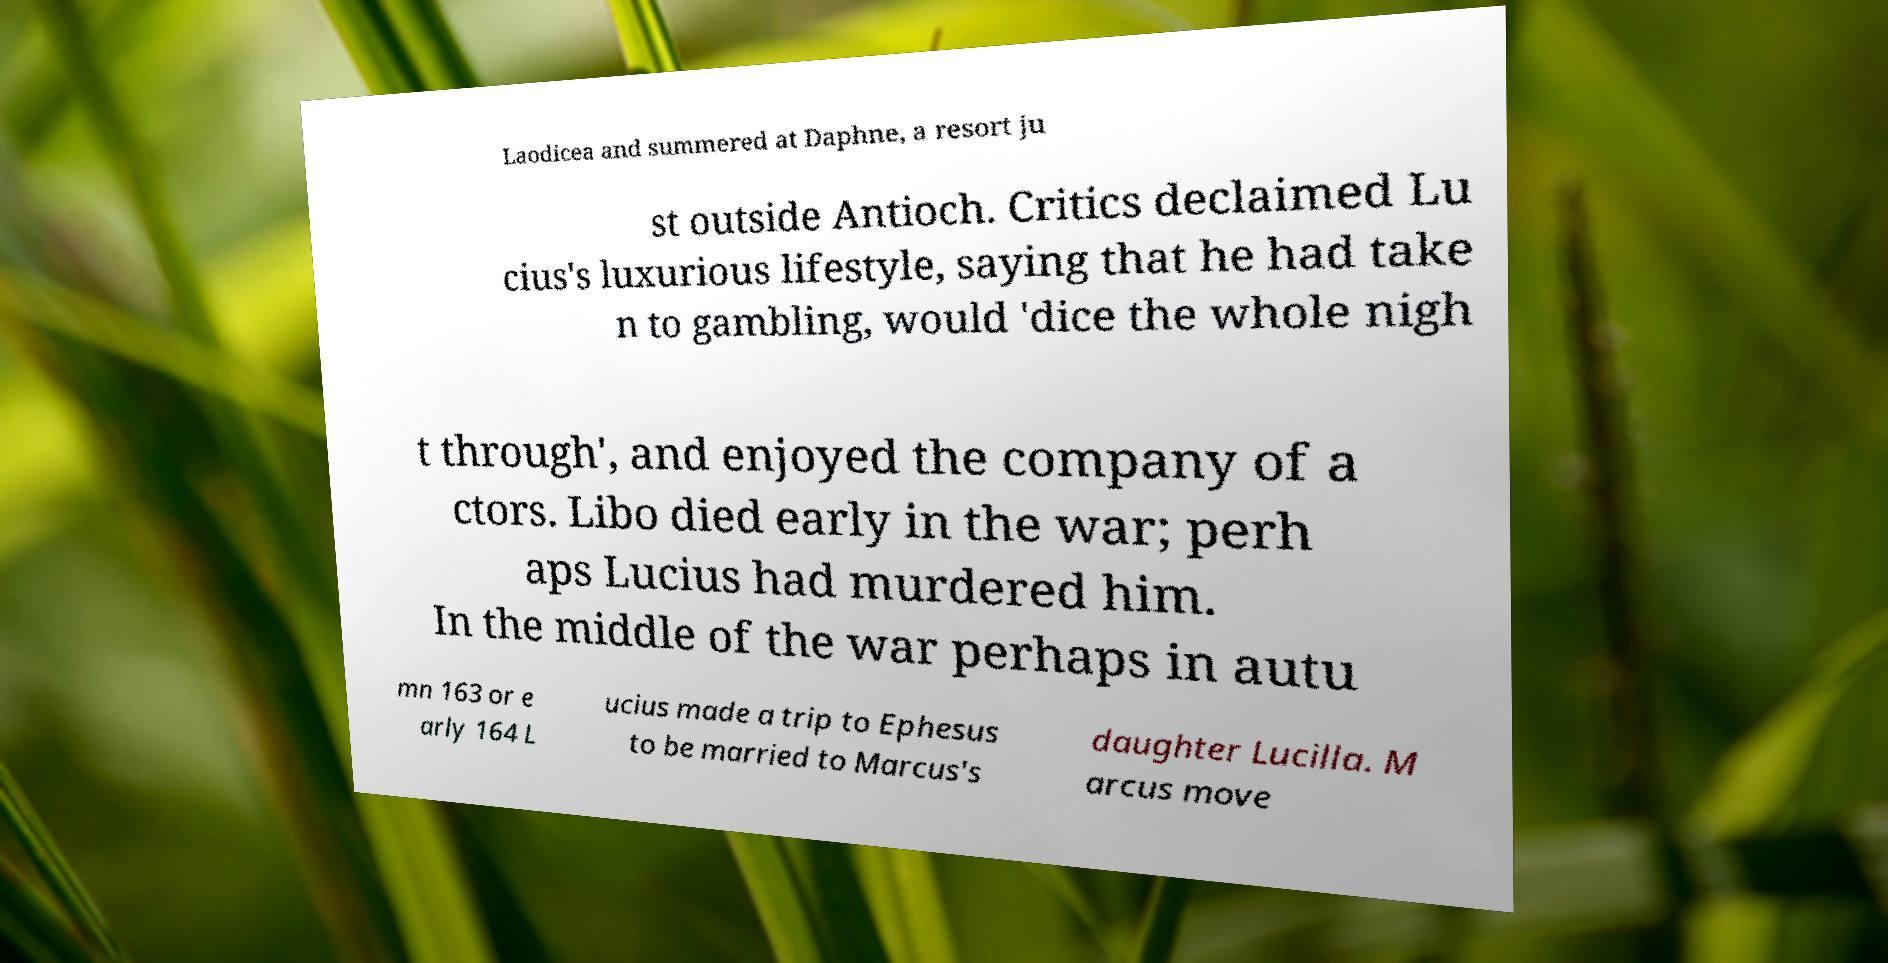What messages or text are displayed in this image? I need them in a readable, typed format. Laodicea and summered at Daphne, a resort ju st outside Antioch. Critics declaimed Lu cius's luxurious lifestyle, saying that he had take n to gambling, would 'dice the whole nigh t through', and enjoyed the company of a ctors. Libo died early in the war; perh aps Lucius had murdered him. In the middle of the war perhaps in autu mn 163 or e arly 164 L ucius made a trip to Ephesus to be married to Marcus's daughter Lucilla. M arcus move 